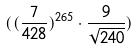<formula> <loc_0><loc_0><loc_500><loc_500>( ( \frac { 7 } { 4 2 8 } ) ^ { 2 6 5 } \cdot \frac { 9 } { \sqrt { 2 4 0 } } )</formula> 